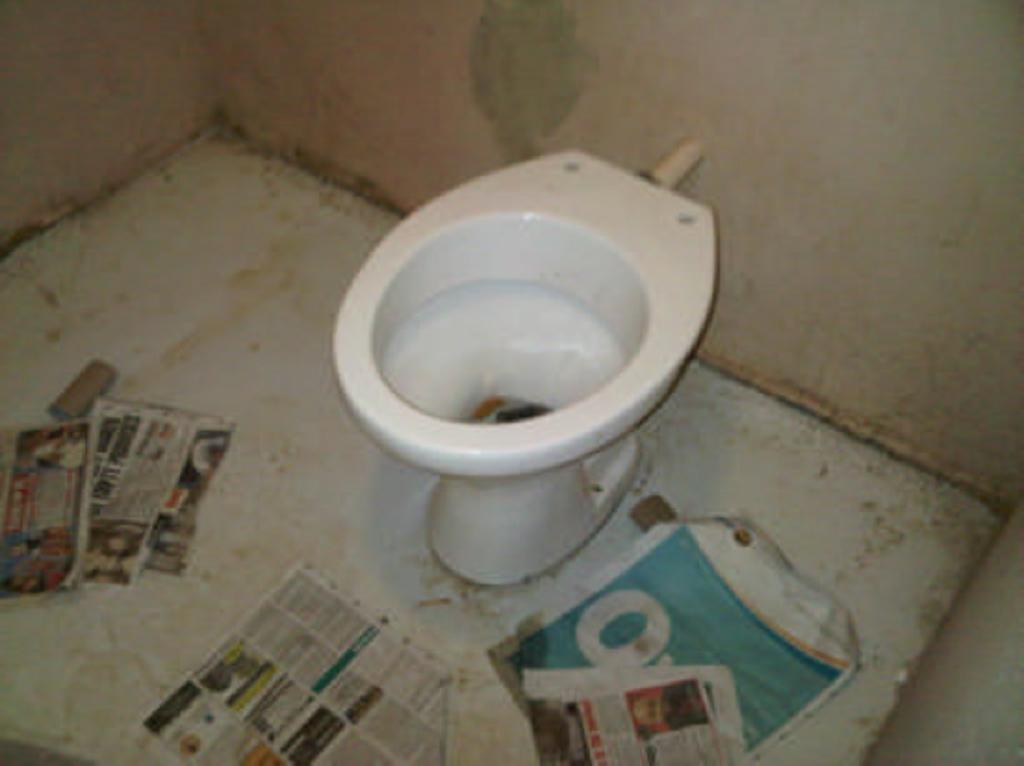What is the main object in the center of the image? There is a commode in the center of the image. Are there any objects on the floor near the commode? Yes, there are papers on the floor in front of the commode. What type of hot unit can be seen next to the commode in the image? There is no hot unit present in the image. 